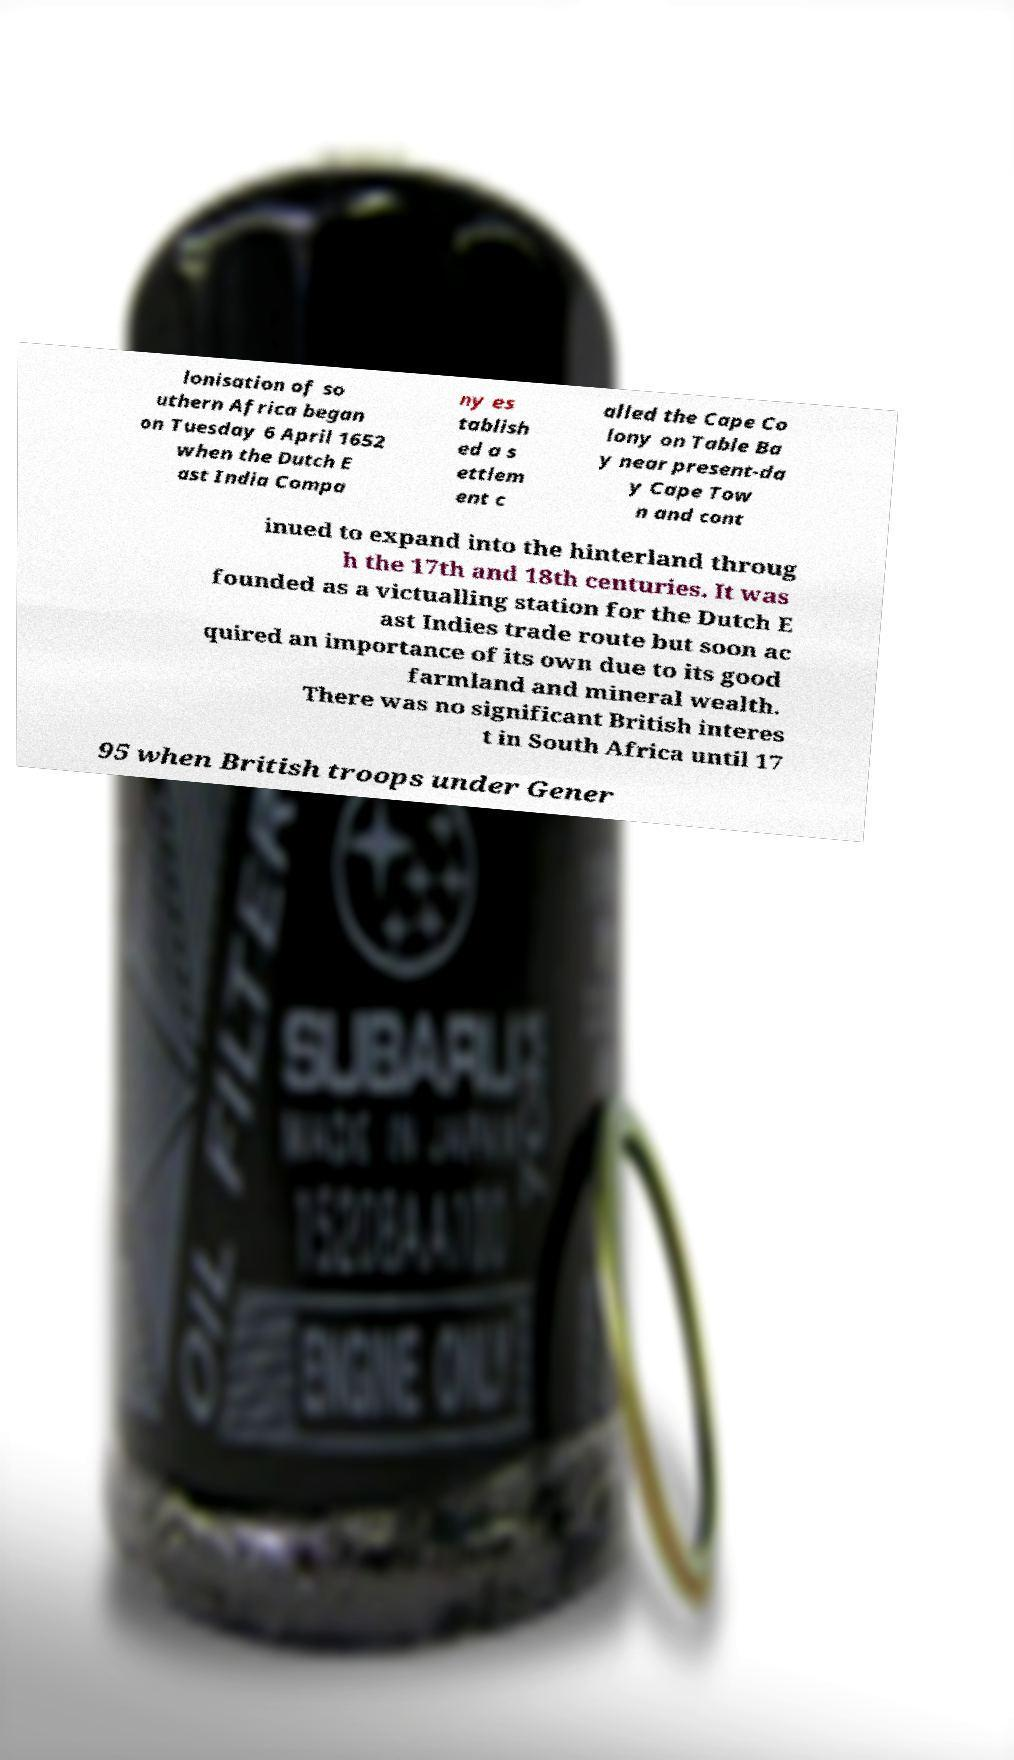What messages or text are displayed in this image? I need them in a readable, typed format. lonisation of so uthern Africa began on Tuesday 6 April 1652 when the Dutch E ast India Compa ny es tablish ed a s ettlem ent c alled the Cape Co lony on Table Ba y near present-da y Cape Tow n and cont inued to expand into the hinterland throug h the 17th and 18th centuries. It was founded as a victualling station for the Dutch E ast Indies trade route but soon ac quired an importance of its own due to its good farmland and mineral wealth. There was no significant British interes t in South Africa until 17 95 when British troops under Gener 